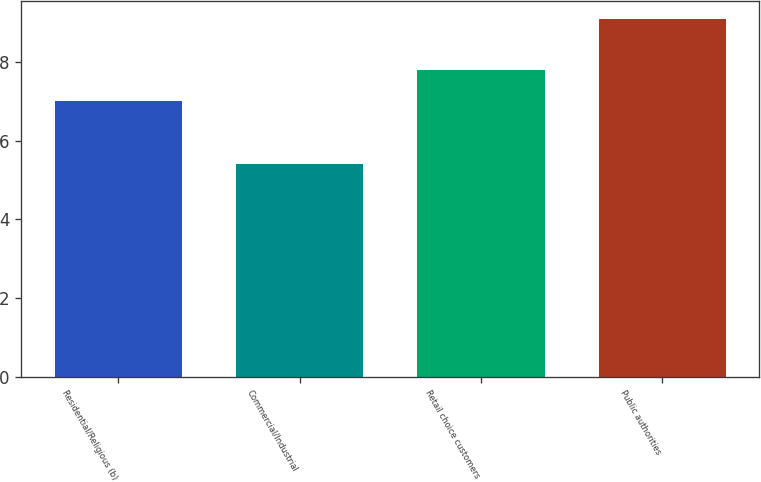Convert chart. <chart><loc_0><loc_0><loc_500><loc_500><bar_chart><fcel>Residential/Religious (b)<fcel>Commercial/Industrial<fcel>Retail choice customers<fcel>Public authorities<nl><fcel>7<fcel>5.4<fcel>7.8<fcel>9.1<nl></chart> 